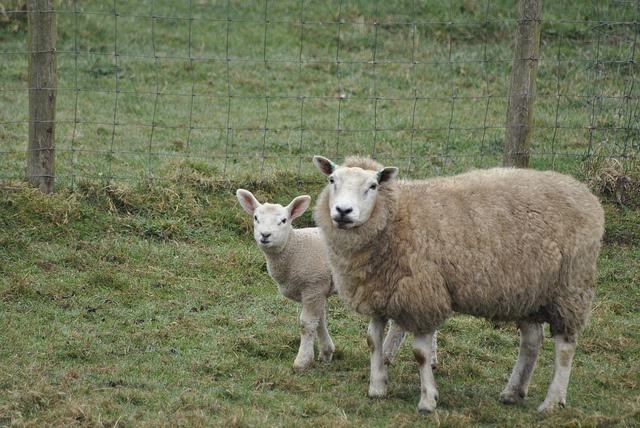Describe the objects in this image and their specific colors. I can see sheep in gray and darkgray tones and sheep in gray, darkgray, and lightgray tones in this image. 